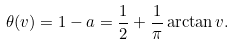<formula> <loc_0><loc_0><loc_500><loc_500>\theta ( v ) = 1 - a = \frac { 1 } { 2 } + \frac { 1 } { \pi } \arctan v .</formula> 